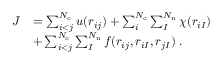<formula> <loc_0><loc_0><loc_500><loc_500>\begin{array} { r l } { J } & { = \sum _ { i < j } ^ { N _ { e } } u ( r _ { i j } ) + \sum _ { i } ^ { N _ { e } } \sum _ { I } ^ { N _ { n } } \chi ( r _ { i I } ) } \\ & { + \sum _ { i < j } ^ { N _ { e } } \sum _ { I } ^ { N _ { n } } f ( r _ { i j } , r _ { i I } , r _ { j I } ) \, . } \end{array}</formula> 